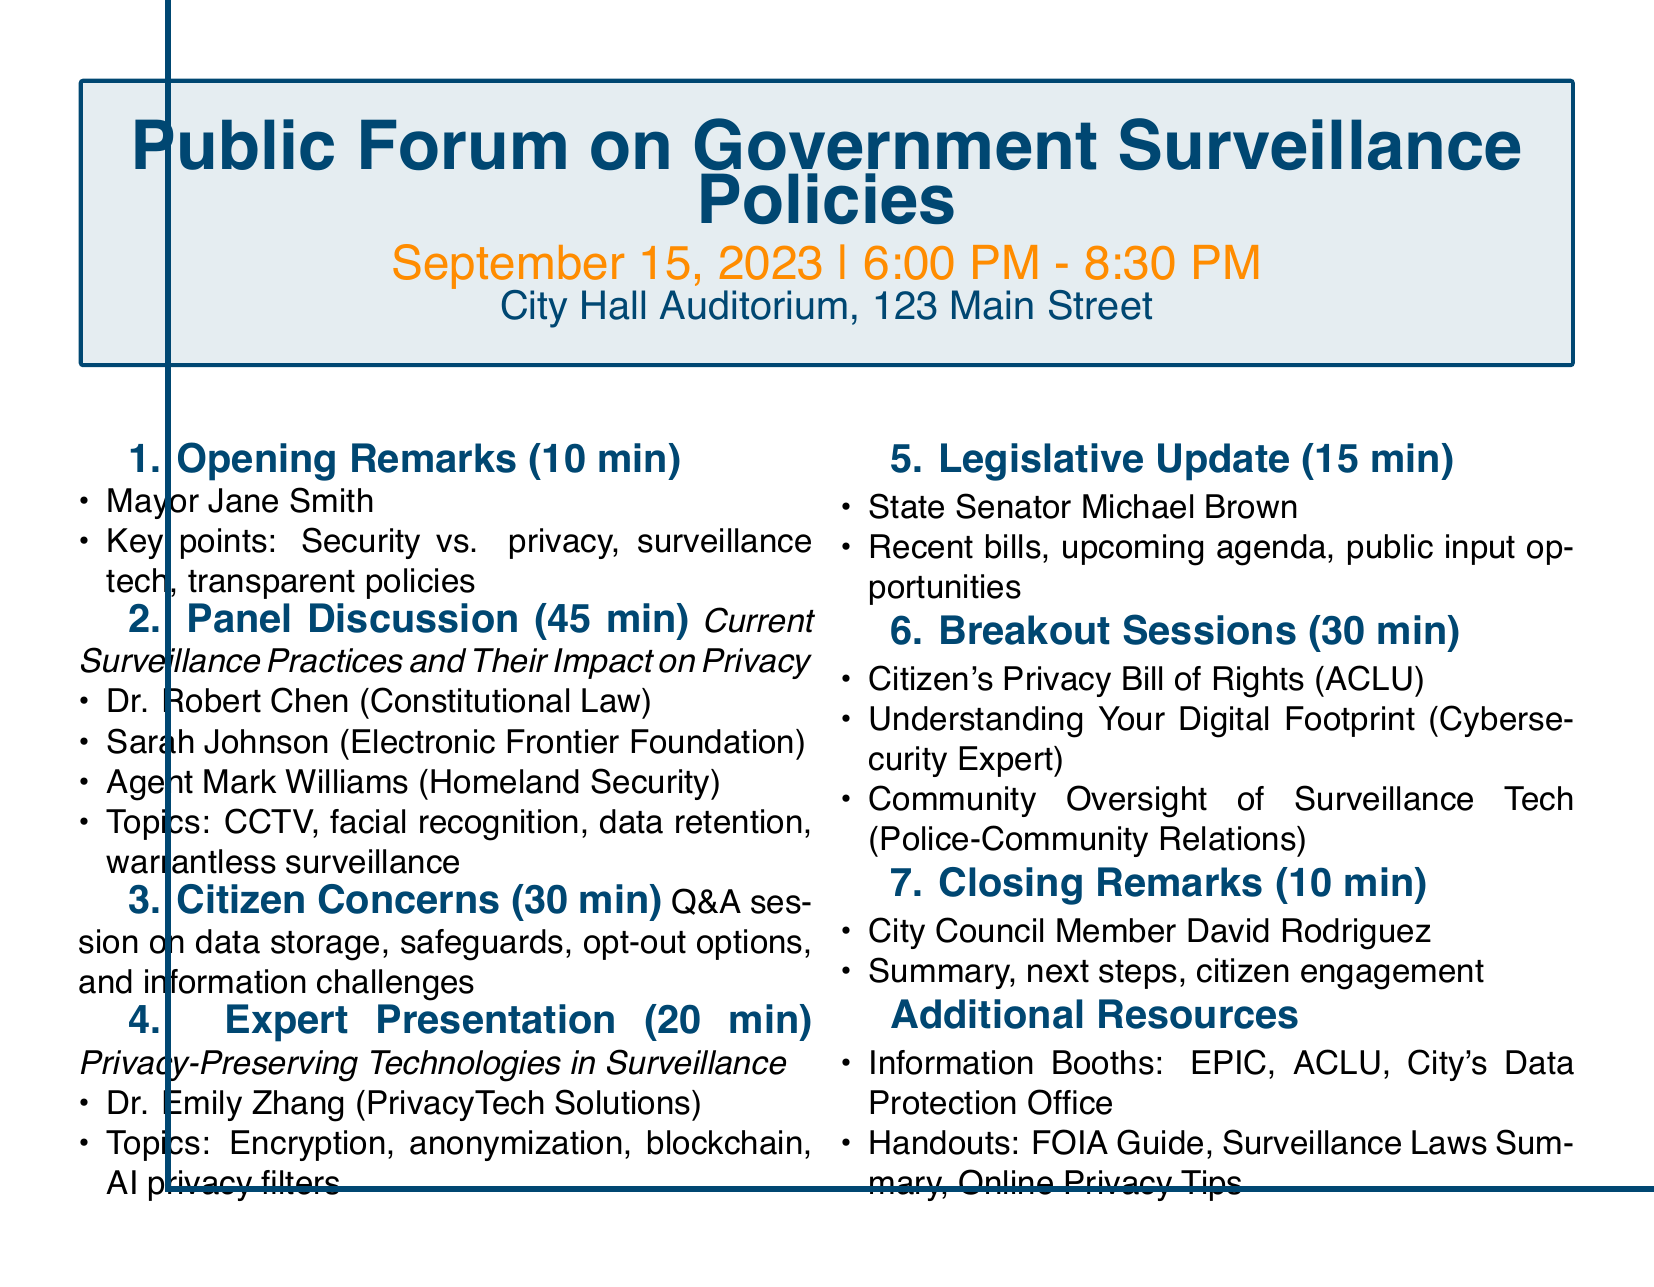What is the date of the Public Forum? The date of the Public Forum is specifically mentioned in the document.
Answer: September 15, 2023 Who is the speaker for the opening remarks? The document lists the speaker for the opening remarks under the opening remarks section.
Answer: Mayor Jane Smith How long is the panel discussion? The duration of the panel discussion is stated in the document.
Answer: 45 minutes What is one of the topics discussed in the panel? The document includes a list of topics covered in the panel discussion.
Answer: Data retention policies Who presents on privacy-preserving technologies? The document contains the name of the speaker for the expert presentation.
Answer: Dr. Emily Zhang What are the potential topics in the breakout sessions? The document lists the topics that will be addressed in the breakout sessions.
Answer: Citizen's Privacy Bill of Rights How long is the citizen concerns Q&A session? The duration of the citizen concerns session is specified in the document.
Answer: 30 minutes What key point does City Council Member David Rodriguez cover in closing remarks? The document includes key points discussed during the closing remarks.
Answer: Next steps in policy development 